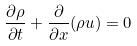Convert formula to latex. <formula><loc_0><loc_0><loc_500><loc_500>\frac { \partial \rho } { \partial t } + \frac { \partial } { \partial x } ( \rho u ) = 0</formula> 